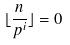Convert formula to latex. <formula><loc_0><loc_0><loc_500><loc_500>\lfloor \frac { n } { p ^ { i } } \rfloor = 0</formula> 